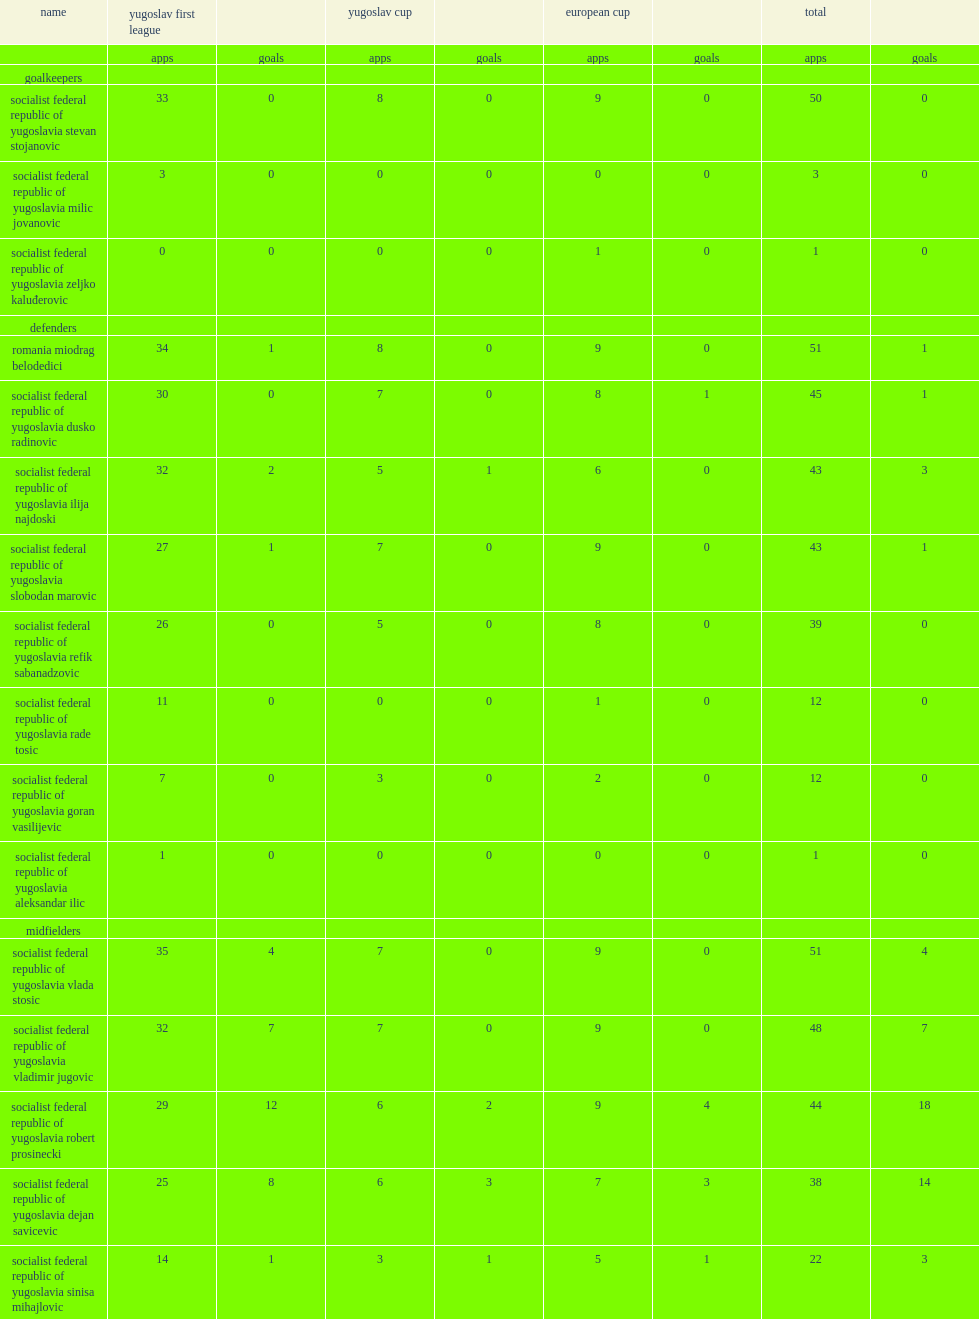List the matches that red star belgrade participated in during the 1990-91 season. Yugoslav first league yugoslav cup european cup. 